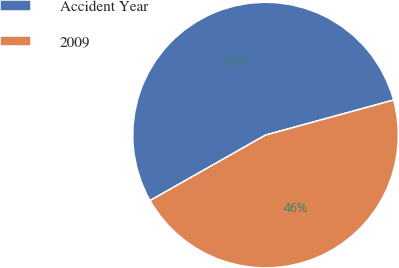<chart> <loc_0><loc_0><loc_500><loc_500><pie_chart><fcel>Accident Year<fcel>2009<nl><fcel>53.96%<fcel>46.04%<nl></chart> 